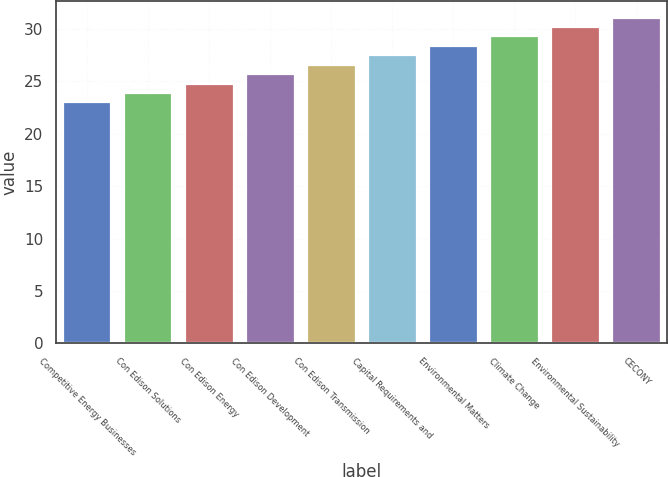Convert chart. <chart><loc_0><loc_0><loc_500><loc_500><bar_chart><fcel>Competitive Energy Businesses<fcel>Con Edison Solutions<fcel>Con Edison Energy<fcel>Con Edison Development<fcel>Con Edison Transmission<fcel>Capital Requirements and<fcel>Environmental Matters<fcel>Climate Change<fcel>Environmental Sustainability<fcel>CECONY<nl><fcel>23<fcel>23.9<fcel>24.8<fcel>25.7<fcel>26.6<fcel>27.5<fcel>28.4<fcel>29.3<fcel>30.2<fcel>31.1<nl></chart> 